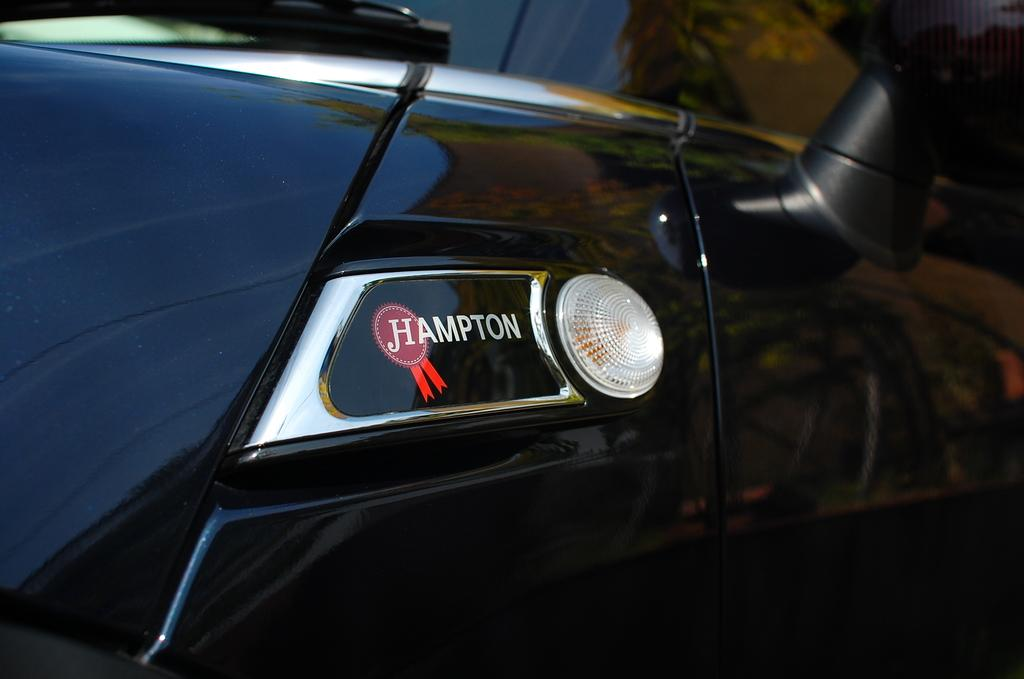What type of vehicle is in the image? There is a black vehicle in the image. Are there any distinguishing features on the vehicle? Yes, there is a light and a logo on the vehicle. What is the purpose of the brain in the image? There is no brain present in the image; it features a black vehicle with a light and a logo. 